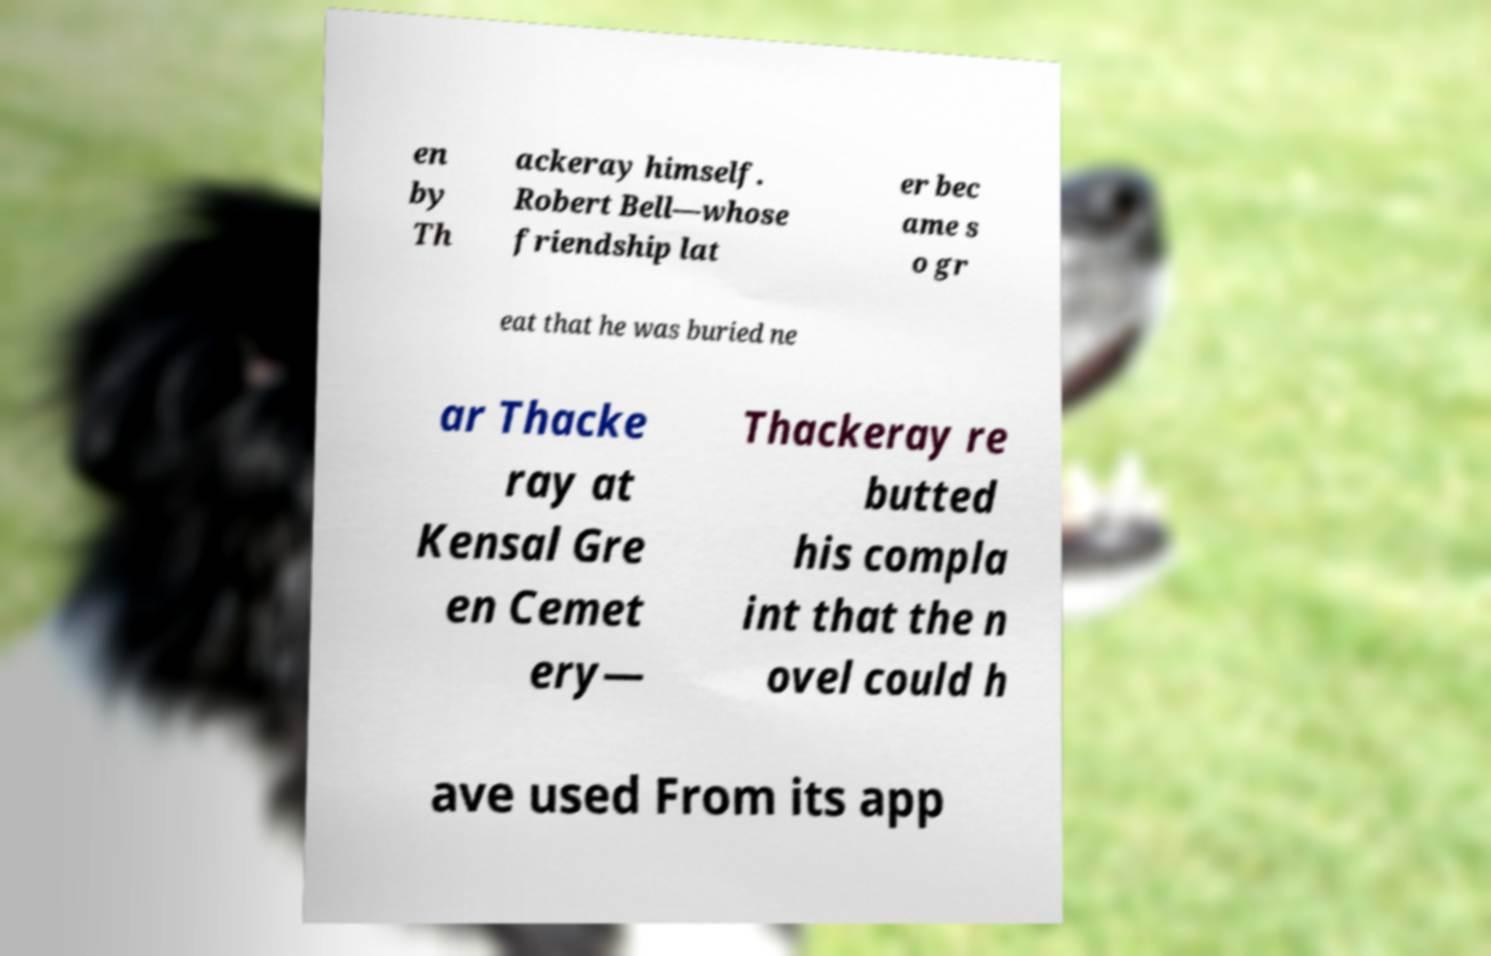Please read and relay the text visible in this image. What does it say? en by Th ackeray himself. Robert Bell—whose friendship lat er bec ame s o gr eat that he was buried ne ar Thacke ray at Kensal Gre en Cemet ery— Thackeray re butted his compla int that the n ovel could h ave used From its app 